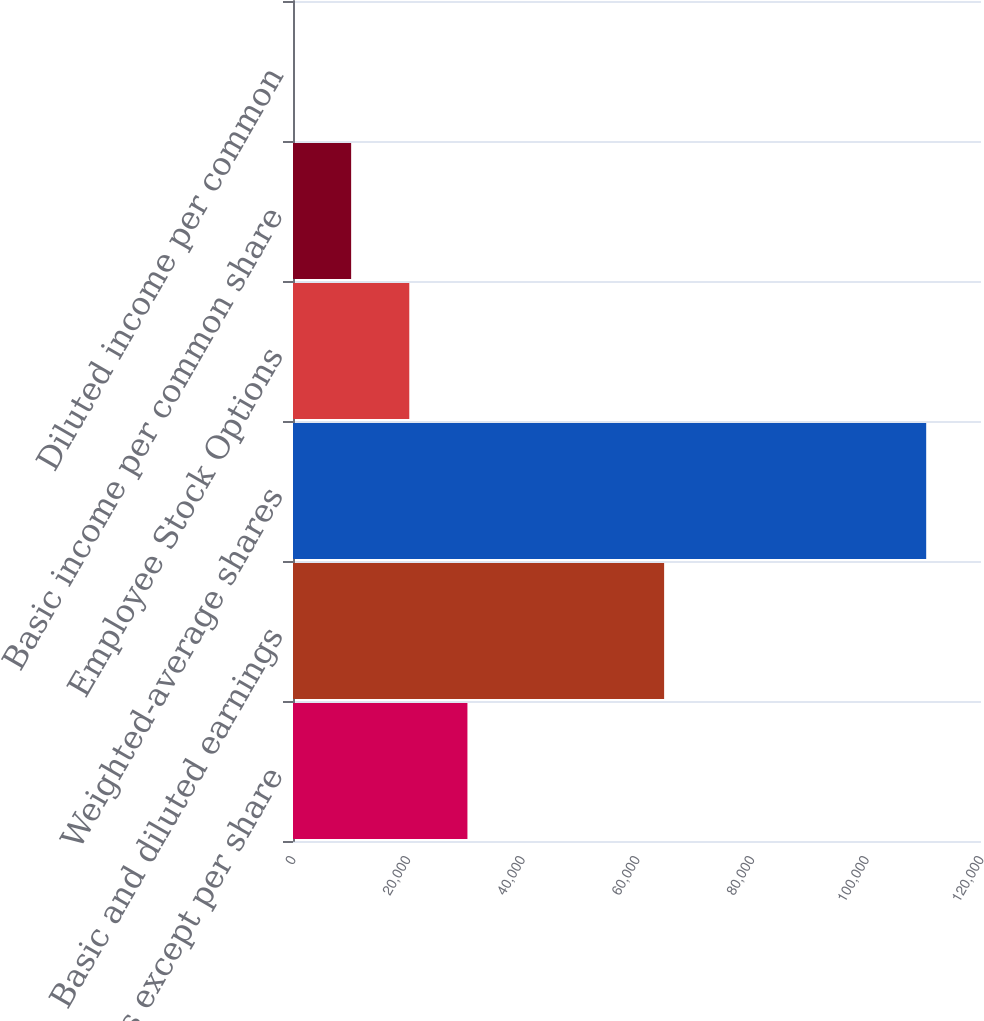Convert chart to OTSL. <chart><loc_0><loc_0><loc_500><loc_500><bar_chart><fcel>(in thousands except per share<fcel>Basic and diluted earnings<fcel>Weighted-average shares<fcel>Employee Stock Options<fcel>Basic income per common share<fcel>Diluted income per common<nl><fcel>30423.2<fcel>64731<fcel>110440<fcel>20282.3<fcel>10141.5<fcel>0.64<nl></chart> 